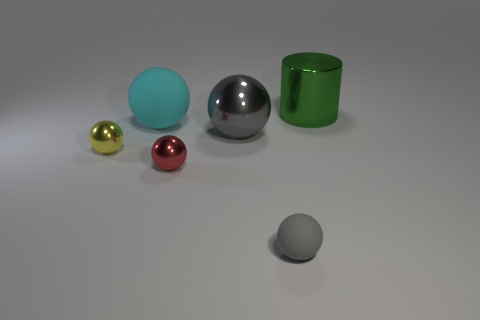Subtract all tiny gray rubber spheres. How many spheres are left? 4 Subtract all cyan spheres. How many spheres are left? 4 Subtract 2 balls. How many balls are left? 3 Add 2 small objects. How many objects exist? 8 Subtract all cylinders. How many objects are left? 5 Subtract all red cylinders. How many red spheres are left? 1 Subtract all brown cylinders. Subtract all yellow balls. How many cylinders are left? 1 Subtract all large cylinders. Subtract all cyan shiny objects. How many objects are left? 5 Add 3 big matte things. How many big matte things are left? 4 Add 6 small gray rubber balls. How many small gray rubber balls exist? 7 